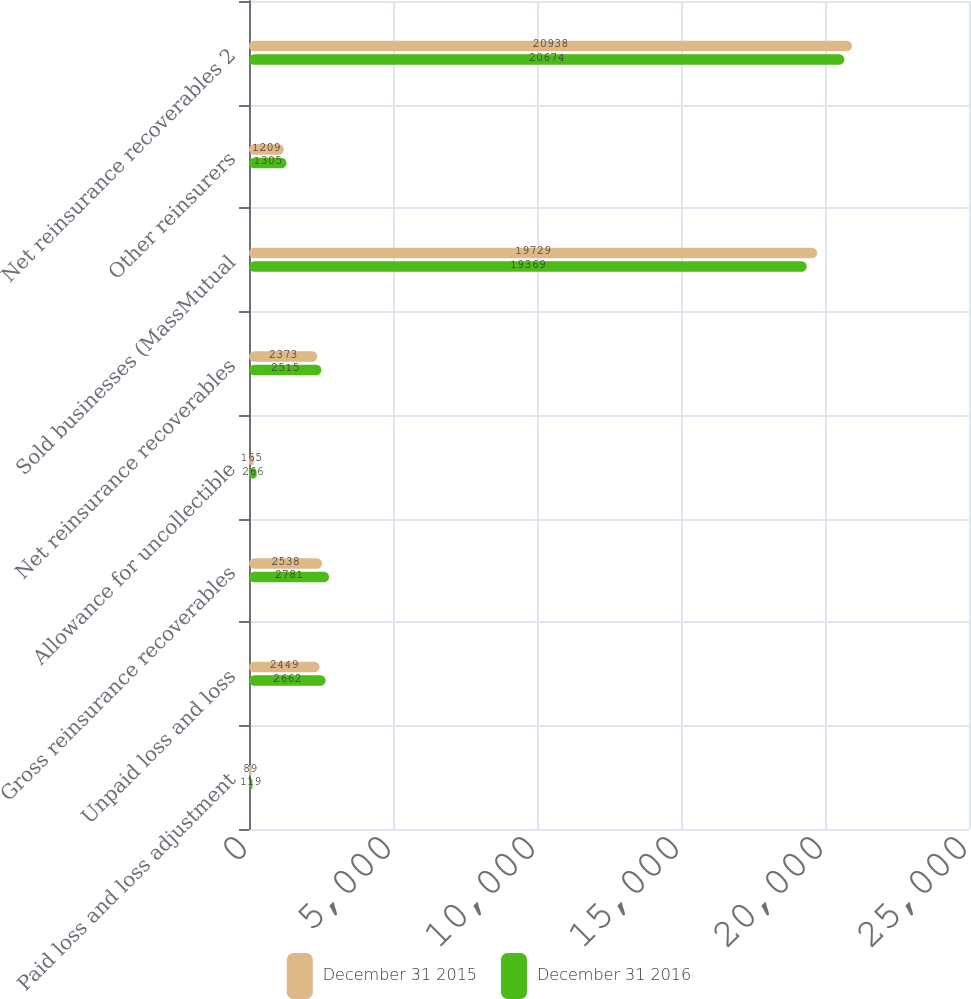<chart> <loc_0><loc_0><loc_500><loc_500><stacked_bar_chart><ecel><fcel>Paid loss and loss adjustment<fcel>Unpaid loss and loss<fcel>Gross reinsurance recoverables<fcel>Allowance for uncollectible<fcel>Net reinsurance recoverables<fcel>Sold businesses (MassMutual<fcel>Other reinsurers<fcel>Net reinsurance recoverables 2<nl><fcel>December 31 2015<fcel>89<fcel>2449<fcel>2538<fcel>165<fcel>2373<fcel>19729<fcel>1209<fcel>20938<nl><fcel>December 31 2016<fcel>119<fcel>2662<fcel>2781<fcel>266<fcel>2515<fcel>19369<fcel>1305<fcel>20674<nl></chart> 